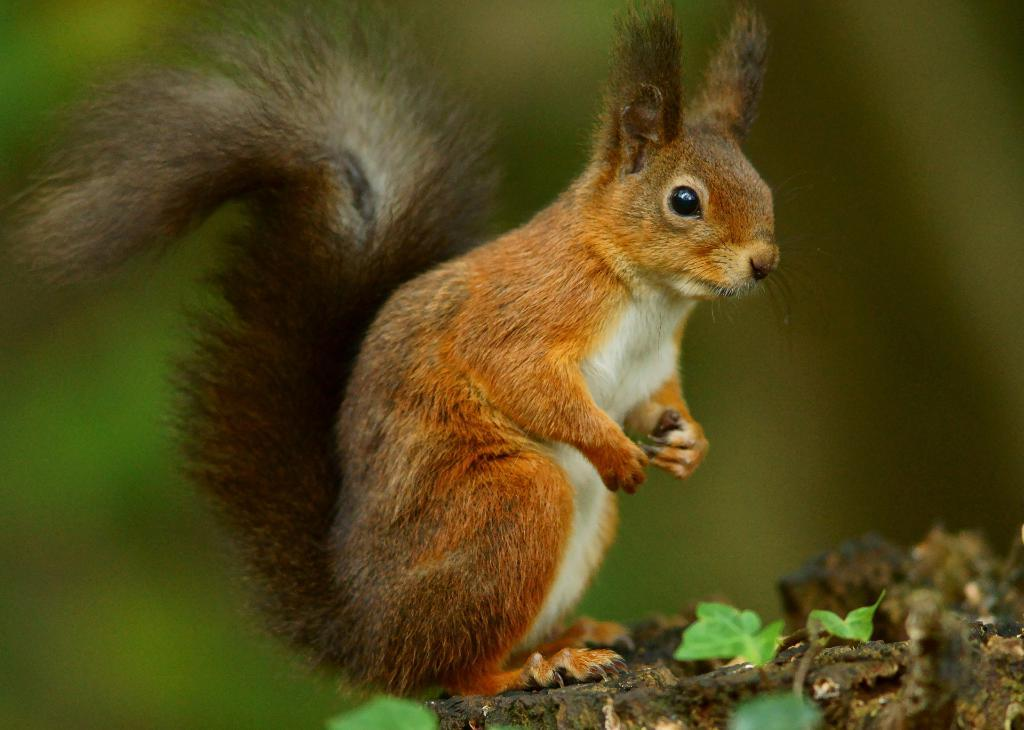What animal can be seen in the image? There is a squirrel in the image. What is the squirrel standing on? The squirrel is standing on a stone. What type of vegetation is present in the image? There are plants in the image. What color dominates the background of the image? The background of the image is green. What type of power source is visible in the image? There is no power source visible in the image; it features a squirrel standing on a stone with plants in the background. How many balls can be seen in the image? There are no balls present in the image. 